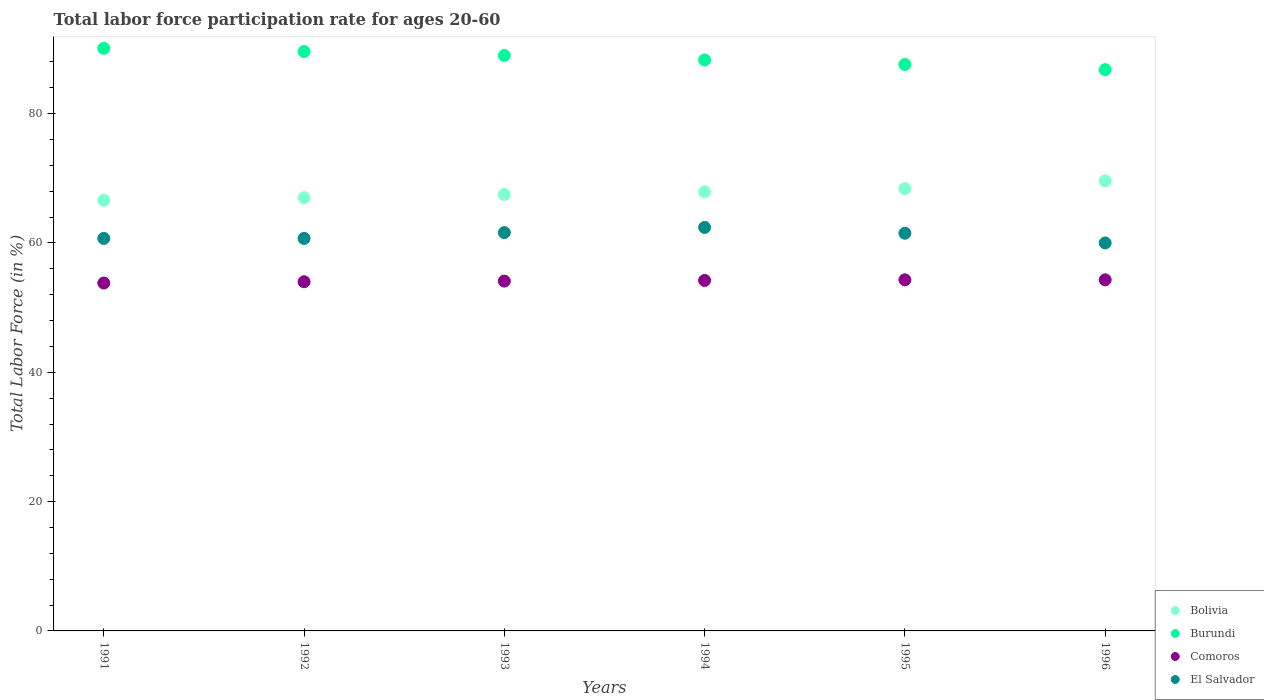What is the labor force participation rate in Burundi in 1993?
Offer a very short reply. 89. Across all years, what is the maximum labor force participation rate in Burundi?
Provide a short and direct response. 90.1. In which year was the labor force participation rate in Comoros maximum?
Make the answer very short. 1995. In which year was the labor force participation rate in Bolivia minimum?
Give a very brief answer. 1991. What is the total labor force participation rate in Comoros in the graph?
Your response must be concise. 324.7. What is the difference between the labor force participation rate in Bolivia in 1992 and that in 1994?
Offer a very short reply. -0.9. What is the difference between the labor force participation rate in El Salvador in 1991 and the labor force participation rate in Burundi in 1996?
Keep it short and to the point. -26.1. What is the average labor force participation rate in El Salvador per year?
Provide a succinct answer. 61.15. In the year 1996, what is the difference between the labor force participation rate in Burundi and labor force participation rate in El Salvador?
Keep it short and to the point. 26.8. What is the ratio of the labor force participation rate in Burundi in 1991 to that in 1992?
Offer a very short reply. 1.01. What is the difference between the highest and the second highest labor force participation rate in El Salvador?
Give a very brief answer. 0.8. Is the sum of the labor force participation rate in Burundi in 1992 and 1995 greater than the maximum labor force participation rate in El Salvador across all years?
Your response must be concise. Yes. Is it the case that in every year, the sum of the labor force participation rate in El Salvador and labor force participation rate in Comoros  is greater than the labor force participation rate in Burundi?
Offer a very short reply. Yes. Does the labor force participation rate in El Salvador monotonically increase over the years?
Make the answer very short. No. How many dotlines are there?
Keep it short and to the point. 4. How many years are there in the graph?
Your answer should be very brief. 6. What is the difference between two consecutive major ticks on the Y-axis?
Offer a terse response. 20. Does the graph contain any zero values?
Keep it short and to the point. No. What is the title of the graph?
Your answer should be compact. Total labor force participation rate for ages 20-60. Does "Small states" appear as one of the legend labels in the graph?
Give a very brief answer. No. What is the Total Labor Force (in %) in Bolivia in 1991?
Offer a very short reply. 66.6. What is the Total Labor Force (in %) of Burundi in 1991?
Make the answer very short. 90.1. What is the Total Labor Force (in %) of Comoros in 1991?
Offer a terse response. 53.8. What is the Total Labor Force (in %) of El Salvador in 1991?
Your response must be concise. 60.7. What is the Total Labor Force (in %) of Burundi in 1992?
Give a very brief answer. 89.6. What is the Total Labor Force (in %) in El Salvador in 1992?
Provide a short and direct response. 60.7. What is the Total Labor Force (in %) in Bolivia in 1993?
Keep it short and to the point. 67.5. What is the Total Labor Force (in %) of Burundi in 1993?
Provide a succinct answer. 89. What is the Total Labor Force (in %) of Comoros in 1993?
Provide a succinct answer. 54.1. What is the Total Labor Force (in %) in El Salvador in 1993?
Provide a short and direct response. 61.6. What is the Total Labor Force (in %) of Bolivia in 1994?
Ensure brevity in your answer.  67.9. What is the Total Labor Force (in %) in Burundi in 1994?
Give a very brief answer. 88.3. What is the Total Labor Force (in %) in Comoros in 1994?
Your answer should be very brief. 54.2. What is the Total Labor Force (in %) in El Salvador in 1994?
Provide a short and direct response. 62.4. What is the Total Labor Force (in %) of Bolivia in 1995?
Make the answer very short. 68.4. What is the Total Labor Force (in %) in Burundi in 1995?
Ensure brevity in your answer.  87.6. What is the Total Labor Force (in %) in Comoros in 1995?
Provide a short and direct response. 54.3. What is the Total Labor Force (in %) in El Salvador in 1995?
Give a very brief answer. 61.5. What is the Total Labor Force (in %) in Bolivia in 1996?
Ensure brevity in your answer.  69.6. What is the Total Labor Force (in %) in Burundi in 1996?
Keep it short and to the point. 86.8. What is the Total Labor Force (in %) of Comoros in 1996?
Give a very brief answer. 54.3. Across all years, what is the maximum Total Labor Force (in %) in Bolivia?
Ensure brevity in your answer.  69.6. Across all years, what is the maximum Total Labor Force (in %) in Burundi?
Your answer should be very brief. 90.1. Across all years, what is the maximum Total Labor Force (in %) of Comoros?
Your answer should be very brief. 54.3. Across all years, what is the maximum Total Labor Force (in %) of El Salvador?
Provide a short and direct response. 62.4. Across all years, what is the minimum Total Labor Force (in %) in Bolivia?
Your answer should be compact. 66.6. Across all years, what is the minimum Total Labor Force (in %) of Burundi?
Offer a terse response. 86.8. Across all years, what is the minimum Total Labor Force (in %) in Comoros?
Ensure brevity in your answer.  53.8. Across all years, what is the minimum Total Labor Force (in %) of El Salvador?
Keep it short and to the point. 60. What is the total Total Labor Force (in %) in Bolivia in the graph?
Make the answer very short. 407. What is the total Total Labor Force (in %) of Burundi in the graph?
Offer a very short reply. 531.4. What is the total Total Labor Force (in %) of Comoros in the graph?
Your answer should be very brief. 324.7. What is the total Total Labor Force (in %) of El Salvador in the graph?
Provide a short and direct response. 366.9. What is the difference between the Total Labor Force (in %) of Bolivia in 1991 and that in 1992?
Keep it short and to the point. -0.4. What is the difference between the Total Labor Force (in %) in Comoros in 1991 and that in 1992?
Your response must be concise. -0.2. What is the difference between the Total Labor Force (in %) in El Salvador in 1991 and that in 1992?
Your answer should be very brief. 0. What is the difference between the Total Labor Force (in %) of Burundi in 1991 and that in 1994?
Give a very brief answer. 1.8. What is the difference between the Total Labor Force (in %) of Comoros in 1991 and that in 1995?
Your answer should be very brief. -0.5. What is the difference between the Total Labor Force (in %) of Bolivia in 1991 and that in 1996?
Keep it short and to the point. -3. What is the difference between the Total Labor Force (in %) in Comoros in 1991 and that in 1996?
Your answer should be very brief. -0.5. What is the difference between the Total Labor Force (in %) of Comoros in 1992 and that in 1993?
Offer a very short reply. -0.1. What is the difference between the Total Labor Force (in %) in Comoros in 1992 and that in 1994?
Your response must be concise. -0.2. What is the difference between the Total Labor Force (in %) in El Salvador in 1992 and that in 1994?
Keep it short and to the point. -1.7. What is the difference between the Total Labor Force (in %) in Bolivia in 1992 and that in 1995?
Your answer should be very brief. -1.4. What is the difference between the Total Labor Force (in %) in Burundi in 1992 and that in 1995?
Offer a very short reply. 2. What is the difference between the Total Labor Force (in %) of Comoros in 1992 and that in 1995?
Offer a very short reply. -0.3. What is the difference between the Total Labor Force (in %) of El Salvador in 1992 and that in 1995?
Give a very brief answer. -0.8. What is the difference between the Total Labor Force (in %) in Comoros in 1992 and that in 1996?
Offer a very short reply. -0.3. What is the difference between the Total Labor Force (in %) of El Salvador in 1993 and that in 1994?
Give a very brief answer. -0.8. What is the difference between the Total Labor Force (in %) of Bolivia in 1993 and that in 1995?
Provide a succinct answer. -0.9. What is the difference between the Total Labor Force (in %) in Comoros in 1993 and that in 1995?
Make the answer very short. -0.2. What is the difference between the Total Labor Force (in %) in El Salvador in 1993 and that in 1995?
Your answer should be compact. 0.1. What is the difference between the Total Labor Force (in %) of Bolivia in 1993 and that in 1996?
Offer a very short reply. -2.1. What is the difference between the Total Labor Force (in %) of El Salvador in 1993 and that in 1996?
Your response must be concise. 1.6. What is the difference between the Total Labor Force (in %) in Burundi in 1994 and that in 1995?
Provide a succinct answer. 0.7. What is the difference between the Total Labor Force (in %) of El Salvador in 1994 and that in 1995?
Keep it short and to the point. 0.9. What is the difference between the Total Labor Force (in %) of Bolivia in 1994 and that in 1996?
Ensure brevity in your answer.  -1.7. What is the difference between the Total Labor Force (in %) in Burundi in 1994 and that in 1996?
Your answer should be compact. 1.5. What is the difference between the Total Labor Force (in %) of El Salvador in 1994 and that in 1996?
Your response must be concise. 2.4. What is the difference between the Total Labor Force (in %) in Comoros in 1995 and that in 1996?
Give a very brief answer. 0. What is the difference between the Total Labor Force (in %) of El Salvador in 1995 and that in 1996?
Keep it short and to the point. 1.5. What is the difference between the Total Labor Force (in %) of Burundi in 1991 and the Total Labor Force (in %) of Comoros in 1992?
Your answer should be compact. 36.1. What is the difference between the Total Labor Force (in %) in Burundi in 1991 and the Total Labor Force (in %) in El Salvador in 1992?
Provide a succinct answer. 29.4. What is the difference between the Total Labor Force (in %) in Bolivia in 1991 and the Total Labor Force (in %) in Burundi in 1993?
Offer a terse response. -22.4. What is the difference between the Total Labor Force (in %) in Burundi in 1991 and the Total Labor Force (in %) in Comoros in 1993?
Keep it short and to the point. 36. What is the difference between the Total Labor Force (in %) of Comoros in 1991 and the Total Labor Force (in %) of El Salvador in 1993?
Make the answer very short. -7.8. What is the difference between the Total Labor Force (in %) of Bolivia in 1991 and the Total Labor Force (in %) of Burundi in 1994?
Your response must be concise. -21.7. What is the difference between the Total Labor Force (in %) of Bolivia in 1991 and the Total Labor Force (in %) of Comoros in 1994?
Ensure brevity in your answer.  12.4. What is the difference between the Total Labor Force (in %) in Burundi in 1991 and the Total Labor Force (in %) in Comoros in 1994?
Ensure brevity in your answer.  35.9. What is the difference between the Total Labor Force (in %) of Burundi in 1991 and the Total Labor Force (in %) of El Salvador in 1994?
Your response must be concise. 27.7. What is the difference between the Total Labor Force (in %) in Bolivia in 1991 and the Total Labor Force (in %) in Burundi in 1995?
Your answer should be very brief. -21. What is the difference between the Total Labor Force (in %) of Bolivia in 1991 and the Total Labor Force (in %) of El Salvador in 1995?
Your response must be concise. 5.1. What is the difference between the Total Labor Force (in %) of Burundi in 1991 and the Total Labor Force (in %) of Comoros in 1995?
Your answer should be very brief. 35.8. What is the difference between the Total Labor Force (in %) of Burundi in 1991 and the Total Labor Force (in %) of El Salvador in 1995?
Offer a very short reply. 28.6. What is the difference between the Total Labor Force (in %) in Bolivia in 1991 and the Total Labor Force (in %) in Burundi in 1996?
Your answer should be compact. -20.2. What is the difference between the Total Labor Force (in %) of Bolivia in 1991 and the Total Labor Force (in %) of El Salvador in 1996?
Offer a terse response. 6.6. What is the difference between the Total Labor Force (in %) in Burundi in 1991 and the Total Labor Force (in %) in Comoros in 1996?
Offer a very short reply. 35.8. What is the difference between the Total Labor Force (in %) in Burundi in 1991 and the Total Labor Force (in %) in El Salvador in 1996?
Offer a very short reply. 30.1. What is the difference between the Total Labor Force (in %) in Comoros in 1991 and the Total Labor Force (in %) in El Salvador in 1996?
Your response must be concise. -6.2. What is the difference between the Total Labor Force (in %) in Bolivia in 1992 and the Total Labor Force (in %) in Comoros in 1993?
Your answer should be compact. 12.9. What is the difference between the Total Labor Force (in %) of Burundi in 1992 and the Total Labor Force (in %) of Comoros in 1993?
Your answer should be very brief. 35.5. What is the difference between the Total Labor Force (in %) in Burundi in 1992 and the Total Labor Force (in %) in El Salvador in 1993?
Your response must be concise. 28. What is the difference between the Total Labor Force (in %) in Comoros in 1992 and the Total Labor Force (in %) in El Salvador in 1993?
Give a very brief answer. -7.6. What is the difference between the Total Labor Force (in %) of Bolivia in 1992 and the Total Labor Force (in %) of Burundi in 1994?
Keep it short and to the point. -21.3. What is the difference between the Total Labor Force (in %) in Burundi in 1992 and the Total Labor Force (in %) in Comoros in 1994?
Your answer should be compact. 35.4. What is the difference between the Total Labor Force (in %) of Burundi in 1992 and the Total Labor Force (in %) of El Salvador in 1994?
Offer a terse response. 27.2. What is the difference between the Total Labor Force (in %) of Bolivia in 1992 and the Total Labor Force (in %) of Burundi in 1995?
Give a very brief answer. -20.6. What is the difference between the Total Labor Force (in %) of Burundi in 1992 and the Total Labor Force (in %) of Comoros in 1995?
Give a very brief answer. 35.3. What is the difference between the Total Labor Force (in %) of Burundi in 1992 and the Total Labor Force (in %) of El Salvador in 1995?
Provide a succinct answer. 28.1. What is the difference between the Total Labor Force (in %) of Bolivia in 1992 and the Total Labor Force (in %) of Burundi in 1996?
Offer a very short reply. -19.8. What is the difference between the Total Labor Force (in %) in Bolivia in 1992 and the Total Labor Force (in %) in Comoros in 1996?
Your answer should be compact. 12.7. What is the difference between the Total Labor Force (in %) in Bolivia in 1992 and the Total Labor Force (in %) in El Salvador in 1996?
Your answer should be very brief. 7. What is the difference between the Total Labor Force (in %) of Burundi in 1992 and the Total Labor Force (in %) of Comoros in 1996?
Your answer should be very brief. 35.3. What is the difference between the Total Labor Force (in %) in Burundi in 1992 and the Total Labor Force (in %) in El Salvador in 1996?
Make the answer very short. 29.6. What is the difference between the Total Labor Force (in %) in Comoros in 1992 and the Total Labor Force (in %) in El Salvador in 1996?
Offer a terse response. -6. What is the difference between the Total Labor Force (in %) in Bolivia in 1993 and the Total Labor Force (in %) in Burundi in 1994?
Give a very brief answer. -20.8. What is the difference between the Total Labor Force (in %) in Bolivia in 1993 and the Total Labor Force (in %) in El Salvador in 1994?
Your answer should be compact. 5.1. What is the difference between the Total Labor Force (in %) in Burundi in 1993 and the Total Labor Force (in %) in Comoros in 1994?
Your response must be concise. 34.8. What is the difference between the Total Labor Force (in %) of Burundi in 1993 and the Total Labor Force (in %) of El Salvador in 1994?
Give a very brief answer. 26.6. What is the difference between the Total Labor Force (in %) of Comoros in 1993 and the Total Labor Force (in %) of El Salvador in 1994?
Offer a terse response. -8.3. What is the difference between the Total Labor Force (in %) of Bolivia in 1993 and the Total Labor Force (in %) of Burundi in 1995?
Offer a terse response. -20.1. What is the difference between the Total Labor Force (in %) in Burundi in 1993 and the Total Labor Force (in %) in Comoros in 1995?
Make the answer very short. 34.7. What is the difference between the Total Labor Force (in %) of Bolivia in 1993 and the Total Labor Force (in %) of Burundi in 1996?
Offer a very short reply. -19.3. What is the difference between the Total Labor Force (in %) of Burundi in 1993 and the Total Labor Force (in %) of Comoros in 1996?
Offer a very short reply. 34.7. What is the difference between the Total Labor Force (in %) of Burundi in 1993 and the Total Labor Force (in %) of El Salvador in 1996?
Offer a terse response. 29. What is the difference between the Total Labor Force (in %) of Comoros in 1993 and the Total Labor Force (in %) of El Salvador in 1996?
Offer a very short reply. -5.9. What is the difference between the Total Labor Force (in %) in Bolivia in 1994 and the Total Labor Force (in %) in Burundi in 1995?
Offer a terse response. -19.7. What is the difference between the Total Labor Force (in %) of Bolivia in 1994 and the Total Labor Force (in %) of El Salvador in 1995?
Offer a very short reply. 6.4. What is the difference between the Total Labor Force (in %) in Burundi in 1994 and the Total Labor Force (in %) in Comoros in 1995?
Your response must be concise. 34. What is the difference between the Total Labor Force (in %) of Burundi in 1994 and the Total Labor Force (in %) of El Salvador in 1995?
Provide a succinct answer. 26.8. What is the difference between the Total Labor Force (in %) of Comoros in 1994 and the Total Labor Force (in %) of El Salvador in 1995?
Give a very brief answer. -7.3. What is the difference between the Total Labor Force (in %) of Bolivia in 1994 and the Total Labor Force (in %) of Burundi in 1996?
Keep it short and to the point. -18.9. What is the difference between the Total Labor Force (in %) of Burundi in 1994 and the Total Labor Force (in %) of El Salvador in 1996?
Provide a succinct answer. 28.3. What is the difference between the Total Labor Force (in %) in Comoros in 1994 and the Total Labor Force (in %) in El Salvador in 1996?
Your answer should be very brief. -5.8. What is the difference between the Total Labor Force (in %) of Bolivia in 1995 and the Total Labor Force (in %) of Burundi in 1996?
Give a very brief answer. -18.4. What is the difference between the Total Labor Force (in %) of Bolivia in 1995 and the Total Labor Force (in %) of El Salvador in 1996?
Provide a succinct answer. 8.4. What is the difference between the Total Labor Force (in %) in Burundi in 1995 and the Total Labor Force (in %) in Comoros in 1996?
Provide a succinct answer. 33.3. What is the difference between the Total Labor Force (in %) of Burundi in 1995 and the Total Labor Force (in %) of El Salvador in 1996?
Keep it short and to the point. 27.6. What is the difference between the Total Labor Force (in %) in Comoros in 1995 and the Total Labor Force (in %) in El Salvador in 1996?
Give a very brief answer. -5.7. What is the average Total Labor Force (in %) in Bolivia per year?
Give a very brief answer. 67.83. What is the average Total Labor Force (in %) in Burundi per year?
Provide a succinct answer. 88.57. What is the average Total Labor Force (in %) in Comoros per year?
Your answer should be very brief. 54.12. What is the average Total Labor Force (in %) in El Salvador per year?
Provide a succinct answer. 61.15. In the year 1991, what is the difference between the Total Labor Force (in %) in Bolivia and Total Labor Force (in %) in Burundi?
Ensure brevity in your answer.  -23.5. In the year 1991, what is the difference between the Total Labor Force (in %) in Burundi and Total Labor Force (in %) in Comoros?
Your answer should be compact. 36.3. In the year 1991, what is the difference between the Total Labor Force (in %) in Burundi and Total Labor Force (in %) in El Salvador?
Keep it short and to the point. 29.4. In the year 1991, what is the difference between the Total Labor Force (in %) in Comoros and Total Labor Force (in %) in El Salvador?
Your answer should be very brief. -6.9. In the year 1992, what is the difference between the Total Labor Force (in %) of Bolivia and Total Labor Force (in %) of Burundi?
Give a very brief answer. -22.6. In the year 1992, what is the difference between the Total Labor Force (in %) in Bolivia and Total Labor Force (in %) in El Salvador?
Offer a terse response. 6.3. In the year 1992, what is the difference between the Total Labor Force (in %) in Burundi and Total Labor Force (in %) in Comoros?
Make the answer very short. 35.6. In the year 1992, what is the difference between the Total Labor Force (in %) of Burundi and Total Labor Force (in %) of El Salvador?
Make the answer very short. 28.9. In the year 1992, what is the difference between the Total Labor Force (in %) of Comoros and Total Labor Force (in %) of El Salvador?
Offer a very short reply. -6.7. In the year 1993, what is the difference between the Total Labor Force (in %) of Bolivia and Total Labor Force (in %) of Burundi?
Provide a succinct answer. -21.5. In the year 1993, what is the difference between the Total Labor Force (in %) of Burundi and Total Labor Force (in %) of Comoros?
Provide a short and direct response. 34.9. In the year 1993, what is the difference between the Total Labor Force (in %) of Burundi and Total Labor Force (in %) of El Salvador?
Your answer should be very brief. 27.4. In the year 1993, what is the difference between the Total Labor Force (in %) in Comoros and Total Labor Force (in %) in El Salvador?
Keep it short and to the point. -7.5. In the year 1994, what is the difference between the Total Labor Force (in %) in Bolivia and Total Labor Force (in %) in Burundi?
Your answer should be very brief. -20.4. In the year 1994, what is the difference between the Total Labor Force (in %) in Burundi and Total Labor Force (in %) in Comoros?
Provide a short and direct response. 34.1. In the year 1994, what is the difference between the Total Labor Force (in %) of Burundi and Total Labor Force (in %) of El Salvador?
Give a very brief answer. 25.9. In the year 1995, what is the difference between the Total Labor Force (in %) in Bolivia and Total Labor Force (in %) in Burundi?
Your answer should be very brief. -19.2. In the year 1995, what is the difference between the Total Labor Force (in %) of Bolivia and Total Labor Force (in %) of El Salvador?
Your answer should be very brief. 6.9. In the year 1995, what is the difference between the Total Labor Force (in %) of Burundi and Total Labor Force (in %) of Comoros?
Ensure brevity in your answer.  33.3. In the year 1995, what is the difference between the Total Labor Force (in %) in Burundi and Total Labor Force (in %) in El Salvador?
Give a very brief answer. 26.1. In the year 1995, what is the difference between the Total Labor Force (in %) in Comoros and Total Labor Force (in %) in El Salvador?
Your answer should be compact. -7.2. In the year 1996, what is the difference between the Total Labor Force (in %) of Bolivia and Total Labor Force (in %) of Burundi?
Provide a succinct answer. -17.2. In the year 1996, what is the difference between the Total Labor Force (in %) in Bolivia and Total Labor Force (in %) in El Salvador?
Provide a succinct answer. 9.6. In the year 1996, what is the difference between the Total Labor Force (in %) of Burundi and Total Labor Force (in %) of Comoros?
Your answer should be compact. 32.5. In the year 1996, what is the difference between the Total Labor Force (in %) in Burundi and Total Labor Force (in %) in El Salvador?
Your answer should be very brief. 26.8. What is the ratio of the Total Labor Force (in %) in Burundi in 1991 to that in 1992?
Offer a terse response. 1.01. What is the ratio of the Total Labor Force (in %) in Comoros in 1991 to that in 1992?
Offer a very short reply. 1. What is the ratio of the Total Labor Force (in %) in Bolivia in 1991 to that in 1993?
Make the answer very short. 0.99. What is the ratio of the Total Labor Force (in %) in Burundi in 1991 to that in 1993?
Give a very brief answer. 1.01. What is the ratio of the Total Labor Force (in %) of El Salvador in 1991 to that in 1993?
Make the answer very short. 0.99. What is the ratio of the Total Labor Force (in %) of Bolivia in 1991 to that in 1994?
Keep it short and to the point. 0.98. What is the ratio of the Total Labor Force (in %) of Burundi in 1991 to that in 1994?
Keep it short and to the point. 1.02. What is the ratio of the Total Labor Force (in %) in Comoros in 1991 to that in 1994?
Make the answer very short. 0.99. What is the ratio of the Total Labor Force (in %) of El Salvador in 1991 to that in 1994?
Your answer should be compact. 0.97. What is the ratio of the Total Labor Force (in %) in Bolivia in 1991 to that in 1995?
Your answer should be compact. 0.97. What is the ratio of the Total Labor Force (in %) of Burundi in 1991 to that in 1995?
Your response must be concise. 1.03. What is the ratio of the Total Labor Force (in %) of Comoros in 1991 to that in 1995?
Offer a terse response. 0.99. What is the ratio of the Total Labor Force (in %) of El Salvador in 1991 to that in 1995?
Offer a terse response. 0.99. What is the ratio of the Total Labor Force (in %) in Bolivia in 1991 to that in 1996?
Provide a short and direct response. 0.96. What is the ratio of the Total Labor Force (in %) of Burundi in 1991 to that in 1996?
Keep it short and to the point. 1.04. What is the ratio of the Total Labor Force (in %) in El Salvador in 1991 to that in 1996?
Your response must be concise. 1.01. What is the ratio of the Total Labor Force (in %) of El Salvador in 1992 to that in 1993?
Keep it short and to the point. 0.99. What is the ratio of the Total Labor Force (in %) of Bolivia in 1992 to that in 1994?
Your answer should be very brief. 0.99. What is the ratio of the Total Labor Force (in %) of Burundi in 1992 to that in 1994?
Keep it short and to the point. 1.01. What is the ratio of the Total Labor Force (in %) in El Salvador in 1992 to that in 1994?
Keep it short and to the point. 0.97. What is the ratio of the Total Labor Force (in %) in Bolivia in 1992 to that in 1995?
Ensure brevity in your answer.  0.98. What is the ratio of the Total Labor Force (in %) of Burundi in 1992 to that in 1995?
Your answer should be very brief. 1.02. What is the ratio of the Total Labor Force (in %) in Bolivia in 1992 to that in 1996?
Your answer should be very brief. 0.96. What is the ratio of the Total Labor Force (in %) of Burundi in 1992 to that in 1996?
Offer a very short reply. 1.03. What is the ratio of the Total Labor Force (in %) in El Salvador in 1992 to that in 1996?
Give a very brief answer. 1.01. What is the ratio of the Total Labor Force (in %) of Bolivia in 1993 to that in 1994?
Provide a short and direct response. 0.99. What is the ratio of the Total Labor Force (in %) in Burundi in 1993 to that in 1994?
Provide a short and direct response. 1.01. What is the ratio of the Total Labor Force (in %) of Comoros in 1993 to that in 1994?
Offer a terse response. 1. What is the ratio of the Total Labor Force (in %) in El Salvador in 1993 to that in 1994?
Give a very brief answer. 0.99. What is the ratio of the Total Labor Force (in %) of El Salvador in 1993 to that in 1995?
Offer a very short reply. 1. What is the ratio of the Total Labor Force (in %) of Bolivia in 1993 to that in 1996?
Your answer should be compact. 0.97. What is the ratio of the Total Labor Force (in %) in Burundi in 1993 to that in 1996?
Keep it short and to the point. 1.03. What is the ratio of the Total Labor Force (in %) in El Salvador in 1993 to that in 1996?
Ensure brevity in your answer.  1.03. What is the ratio of the Total Labor Force (in %) in Burundi in 1994 to that in 1995?
Ensure brevity in your answer.  1.01. What is the ratio of the Total Labor Force (in %) of Comoros in 1994 to that in 1995?
Provide a succinct answer. 1. What is the ratio of the Total Labor Force (in %) in El Salvador in 1994 to that in 1995?
Provide a succinct answer. 1.01. What is the ratio of the Total Labor Force (in %) of Bolivia in 1994 to that in 1996?
Make the answer very short. 0.98. What is the ratio of the Total Labor Force (in %) in Burundi in 1994 to that in 1996?
Offer a terse response. 1.02. What is the ratio of the Total Labor Force (in %) of Comoros in 1994 to that in 1996?
Provide a short and direct response. 1. What is the ratio of the Total Labor Force (in %) of El Salvador in 1994 to that in 1996?
Your response must be concise. 1.04. What is the ratio of the Total Labor Force (in %) of Bolivia in 1995 to that in 1996?
Your answer should be very brief. 0.98. What is the ratio of the Total Labor Force (in %) of Burundi in 1995 to that in 1996?
Your answer should be very brief. 1.01. What is the ratio of the Total Labor Force (in %) in Comoros in 1995 to that in 1996?
Provide a succinct answer. 1. What is the ratio of the Total Labor Force (in %) in El Salvador in 1995 to that in 1996?
Provide a succinct answer. 1.02. What is the difference between the highest and the second highest Total Labor Force (in %) of Bolivia?
Your answer should be compact. 1.2. What is the difference between the highest and the second highest Total Labor Force (in %) of Comoros?
Offer a very short reply. 0. What is the difference between the highest and the lowest Total Labor Force (in %) of Burundi?
Offer a terse response. 3.3. 